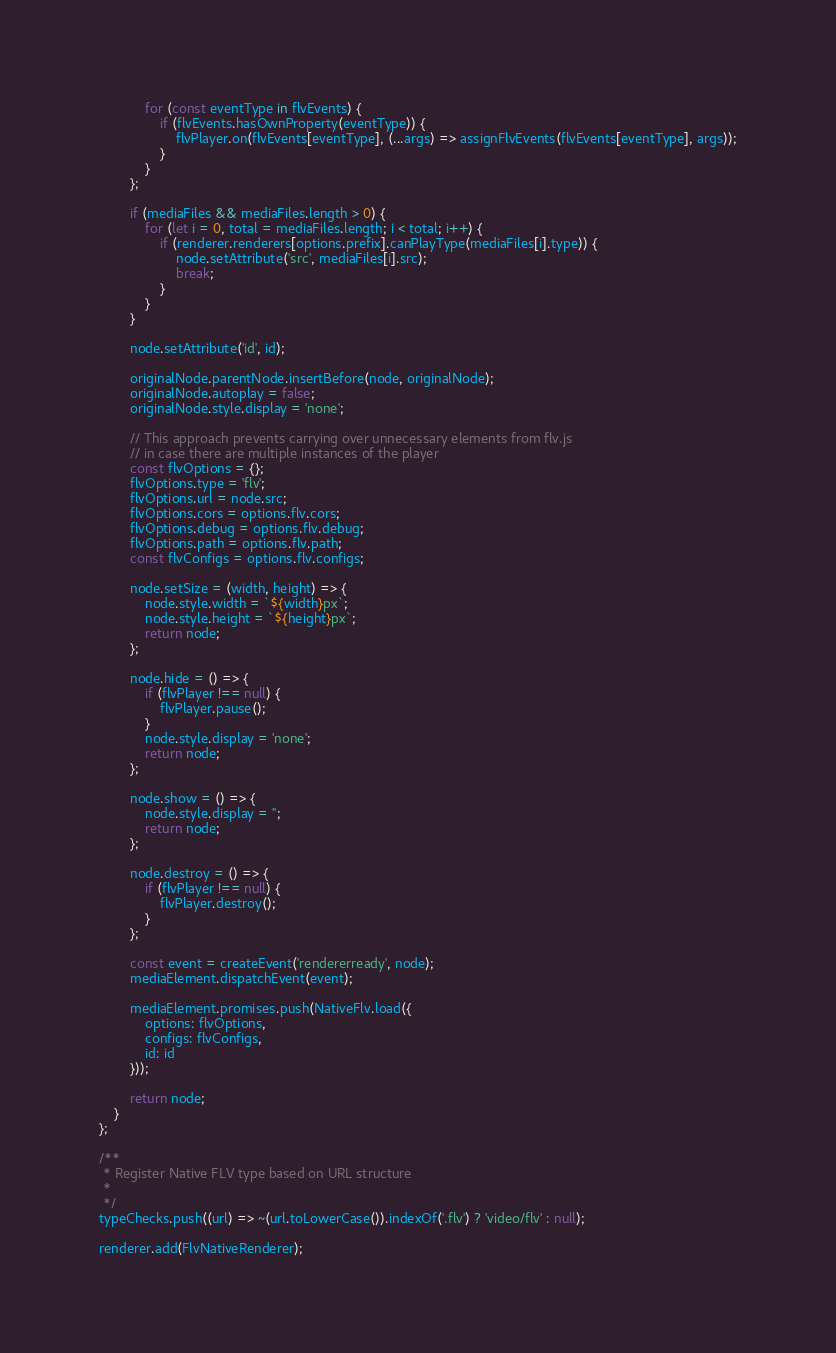Convert code to text. <code><loc_0><loc_0><loc_500><loc_500><_JavaScript_>
			for (const eventType in flvEvents) {
				if (flvEvents.hasOwnProperty(eventType)) {
					flvPlayer.on(flvEvents[eventType], (...args) => assignFlvEvents(flvEvents[eventType], args));
				}
			}
		};

		if (mediaFiles && mediaFiles.length > 0) {
			for (let i = 0, total = mediaFiles.length; i < total; i++) {
				if (renderer.renderers[options.prefix].canPlayType(mediaFiles[i].type)) {
					node.setAttribute('src', mediaFiles[i].src);
					break;
				}
			}
		}

		node.setAttribute('id', id);

		originalNode.parentNode.insertBefore(node, originalNode);
		originalNode.autoplay = false;
		originalNode.style.display = 'none';

		// This approach prevents carrying over unnecessary elements from flv.js
		// in case there are multiple instances of the player
		const flvOptions = {};
		flvOptions.type = 'flv';
		flvOptions.url = node.src;
		flvOptions.cors = options.flv.cors;
		flvOptions.debug = options.flv.debug;
		flvOptions.path = options.flv.path;
		const flvConfigs = options.flv.configs;

		node.setSize = (width, height) => {
			node.style.width = `${width}px`;
			node.style.height = `${height}px`;
			return node;
		};

		node.hide = () => {
			if (flvPlayer !== null) {
				flvPlayer.pause();
			}
			node.style.display = 'none';
			return node;
		};

		node.show = () => {
			node.style.display = '';
			return node;
		};

		node.destroy = () => {
			if (flvPlayer !== null) {
				flvPlayer.destroy();
			}
		};

		const event = createEvent('rendererready', node);
		mediaElement.dispatchEvent(event);

		mediaElement.promises.push(NativeFlv.load({
			options: flvOptions,
			configs: flvConfigs,
			id: id
		}));

		return node;
	}
};

/**
 * Register Native FLV type based on URL structure
 *
 */
typeChecks.push((url) => ~(url.toLowerCase()).indexOf('.flv') ? 'video/flv' : null);

renderer.add(FlvNativeRenderer);
</code> 